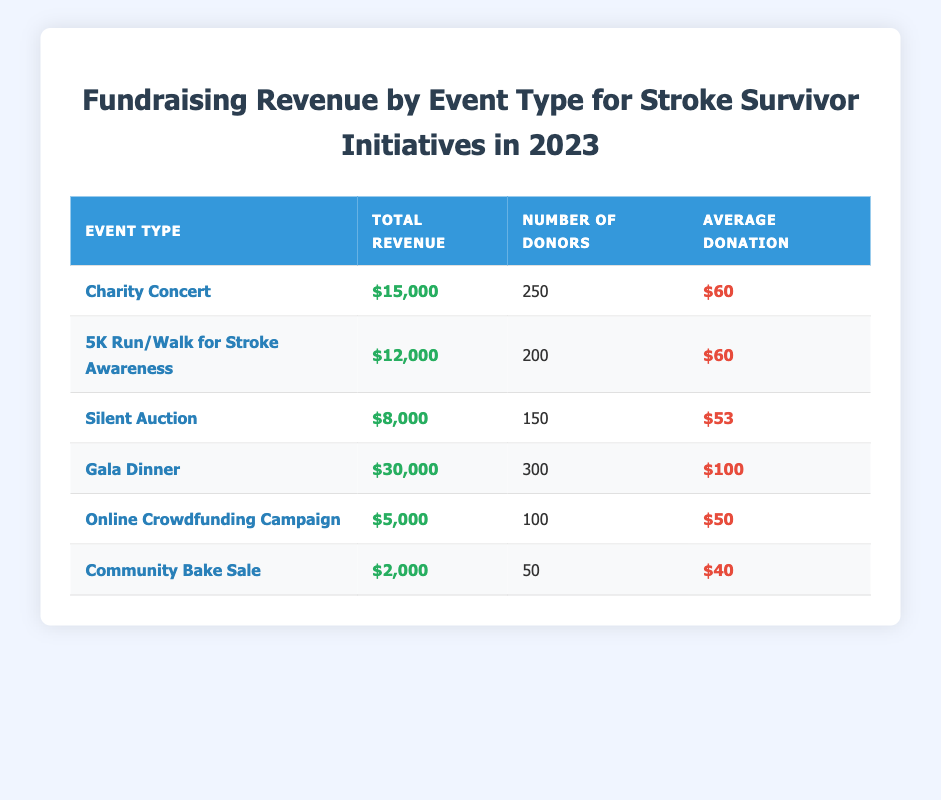What is the total revenue generated by the Gala Dinner event? The table shows that the total revenue for the Gala Dinner is listed directly, which is $30,000.
Answer: $30,000 How many donors contributed to the Charity Concert? By looking at the table, the number of donors for the Charity Concert is 250.
Answer: 250 What is the average donation amount from the Silent Auction? The average donation amount can be found in the table under the Silent Auction row, which shows $53.
Answer: $53 Which fundraising event had the lowest revenue, and what was the amount? The table shows the total revenue for all events. The Community Bake Sale has the lowest revenue, which is $2,000.
Answer: Community Bake Sale, $2,000 How much more revenue did the Gala Dinner generate compared to the Online Crowdfunding Campaign? The total revenue for the Gala Dinner is $30,000, and for the Online Crowdfunding Campaign, it is $5,000. Subtracting these amounts gives $30,000 - $5,000 = $25,000.
Answer: $25,000 Is the average donation for the 5K Run/Walk for Stroke Awareness the same as that for the Charity Concert? The average donation for the 5K Run/Walk for Stroke Awareness is $60, and for the Charity Concert, it is also $60. Therefore, they are the same.
Answer: Yes What is the total revenue from all events combined? To find the total revenue, sum the revenues of all the events: $15,000 (Charity Concert) + $12,000 (5K Run/Walk) + $8,000 (Silent Auction) + $30,000 (Gala Dinner) + $5,000 (Online Crowdfunding) + $2,000 (Bake Sale) = $72,000.
Answer: $72,000 How many total donors contributed across all fundraising events? By adding up the number of donors from each event: 250 (Charity Concert) + 200 (5K Run/Walk) + 150 (Silent Auction) + 300 (Gala Dinner) + 100 (Online Crowdfunding) + 50 (Bake Sale) = 1,050 total donors.
Answer: 1,050 Which event had the highest average donation and what was that amount? Looking at the average donations, the Gala Dinner has the highest average donation at $100.
Answer: Gala Dinner, $100 